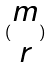Convert formula to latex. <formula><loc_0><loc_0><loc_500><loc_500>( \begin{matrix} m \\ r \end{matrix} )</formula> 